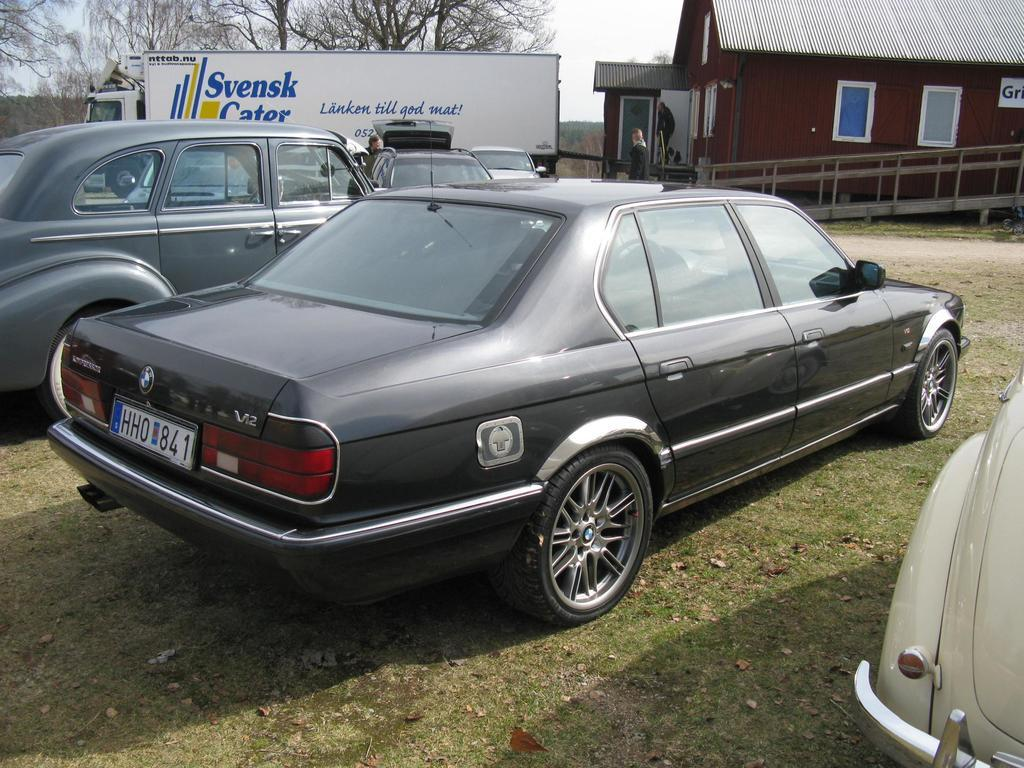What type of vehicles are on the ground in the image? There are cars on the ground in the image. What other type of vehicle can be seen in the image? There is a truck visible in the background of the image. What structures are visible in the background of the image? There are houses in the background of the image. What type of vegetation is visible in the background of the image? There are trees in the background of the image. What holiday is being celebrated in the image? There is no indication of a holiday being celebrated in the image. Can you tell me how many girls are present in the image? There is no mention of a girl or any people in the image. 